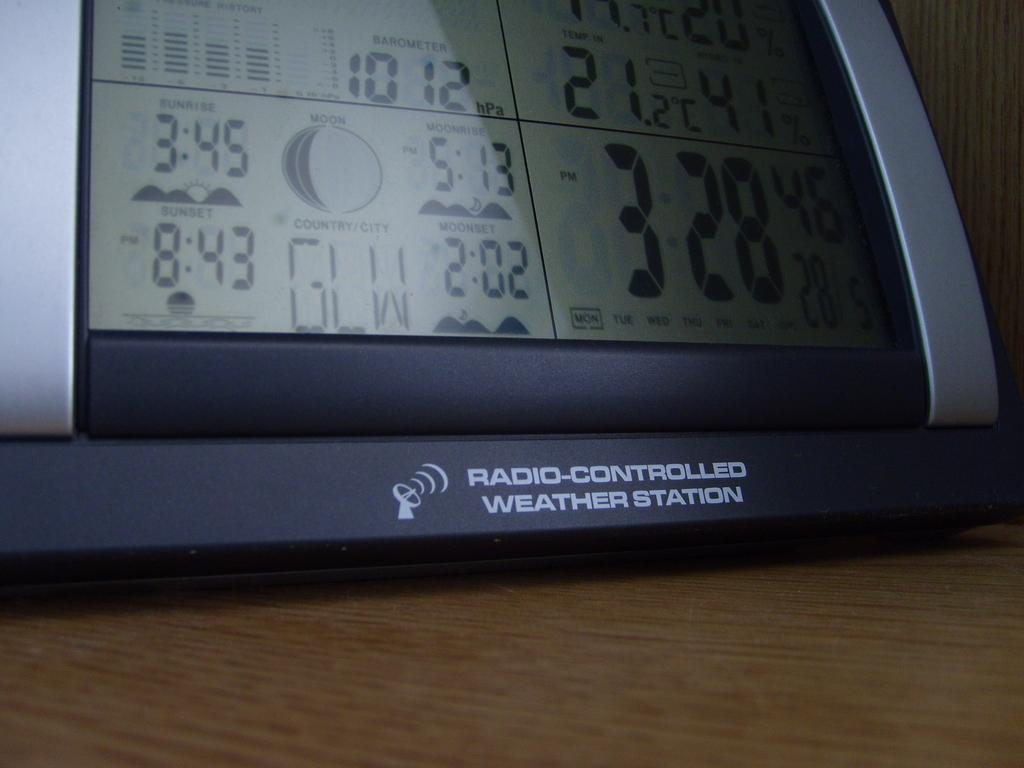What time is it?
Provide a succinct answer. 3:28. 